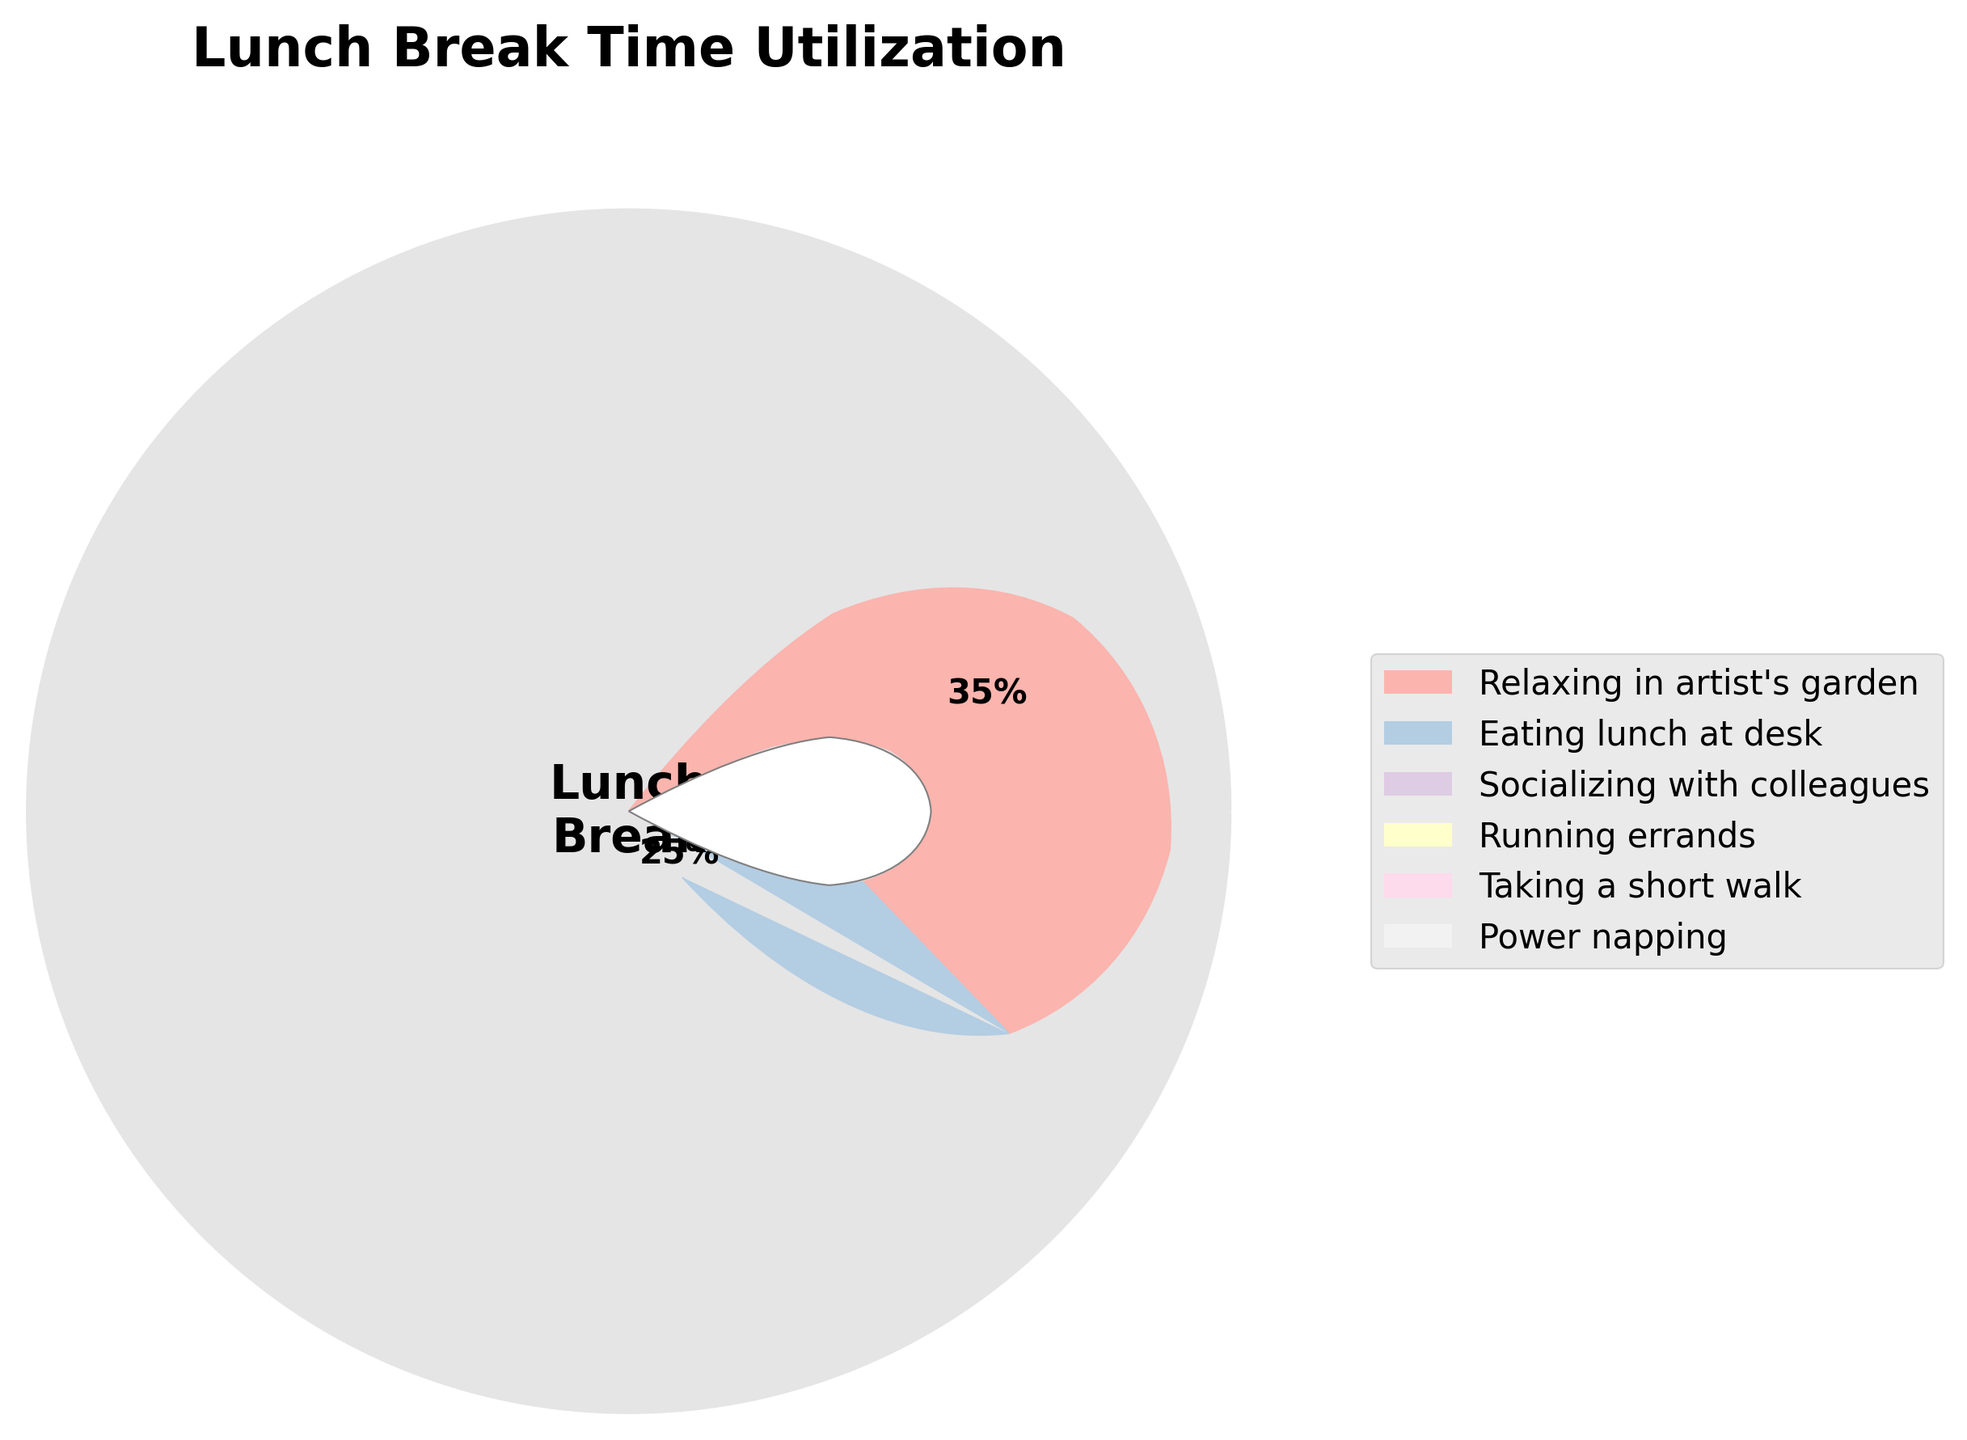What's the title of the figure? The title is displayed prominently at the top of the figure. It usually describes the subject or focus of the figure. In this case, the title is placed above the gauge chart.
Answer: Lunch Break Time Utilization Which activity takes up the largest percentage of lunch break time? Identify the activity associated with the largest segment of the gauge chart. The percentage text near each segment helps in determining this.
Answer: Relaxing in artist's garden How much time do workers spend eating lunch at their desk compared to socializing with colleagues? Compare the percentages associated with "Eating lunch at desk" and "Socializing with colleagues" by finding and contrasting their values.
Answer: 25% vs 20% What is the combined percentage of time spent running errands and taking a short walk? Add the percentages for "Running errands" and "Taking a short walk". According to the gauge chart, these are positioned next to each other.
Answer: 10% + 8% = 18% Which activities are represented by colors on the gauge chart, and how many are there? Count the number of distinct segments (activities) in the gauge chart and list them. Each activity is represented by a different color and labeled with a percentage.
Answer: Six activities: Relaxing in artist's garden, Eating lunch at desk, Socializing with colleagues, Running errands, Taking a short walk, Power napping Compare the percentage of workers power napping to those taking a short walk. Look at the percentage values corresponding to "Power napping" and "Taking a short walk" segments, and determine how they relate to each other.
Answer: 2% vs 8% How does the time spent relaxing in the artist's garden compare to the time spent eating lunch at the desk and running errands combined? Compare the percentage for "Relaxing in artist's garden" with the sum of "Eating lunch at desk" and "Running errands".
Answer: 35% vs 25% + 10% = 35% Which activity takes up the smallest percentage of lunch break time? Identify the smallest segment in the gauge chart and check the label for its corresponding activity and percentage.
Answer: Power napping What is the difference in percentage between the time spent socializing with colleagues and power napping? Subtract the percentage for "Power napping" from "Socializing with colleagues" to find the difference.
Answer: 20% - 2% = 18% What is the midpoint angle for the segment representing running errands, if each percentage point is equal to 3.6 degrees? Calculate the start and end angles for "Running errands" based on its percentage, then find the average of these angles to determine the midpoint angle in degrees.
Answer: Start angle = 90 degrees, End angle = (10 * 3.6) + 90 = 126 degrees. Midpoint angle = (90 + 126) / 2 = 108 degrees 